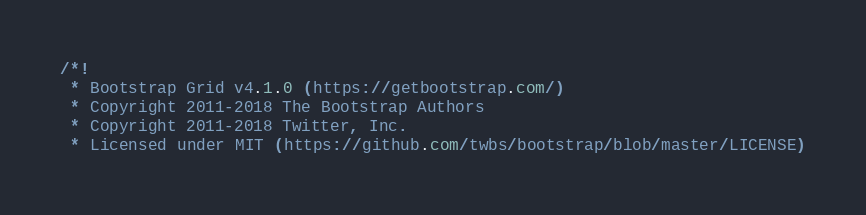Convert code to text. <code><loc_0><loc_0><loc_500><loc_500><_CSS_>/*!
 * Bootstrap Grid v4.1.0 (https://getbootstrap.com/)
 * Copyright 2011-2018 The Bootstrap Authors
 * Copyright 2011-2018 Twitter, Inc.
 * Licensed under MIT (https://github.com/twbs/bootstrap/blob/master/LICENSE)</code> 